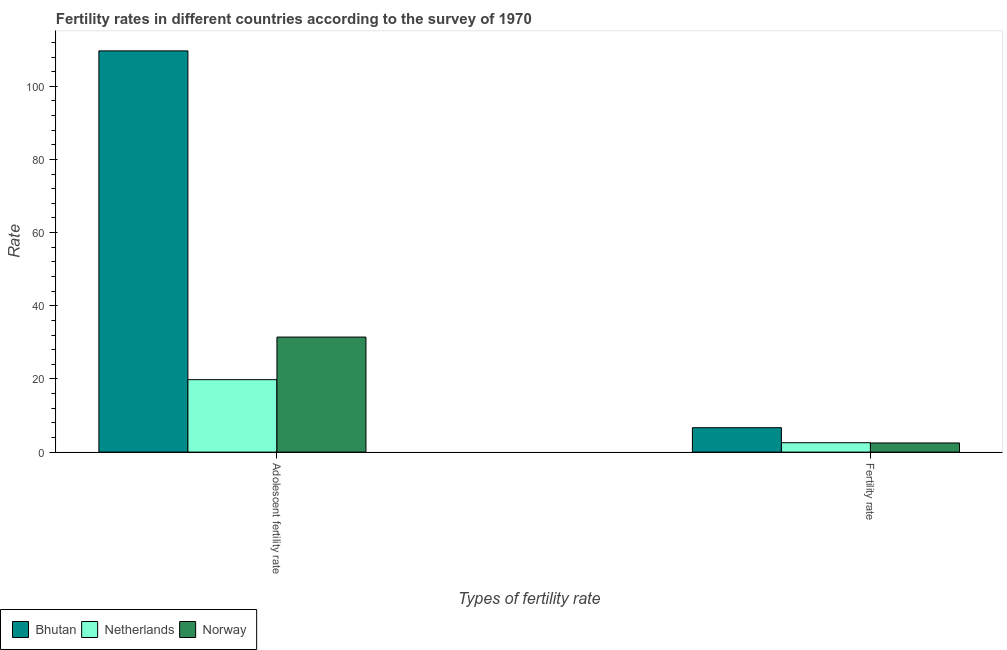How many different coloured bars are there?
Provide a succinct answer. 3. Are the number of bars per tick equal to the number of legend labels?
Ensure brevity in your answer.  Yes. Are the number of bars on each tick of the X-axis equal?
Keep it short and to the point. Yes. How many bars are there on the 2nd tick from the left?
Offer a terse response. 3. How many bars are there on the 1st tick from the right?
Give a very brief answer. 3. What is the label of the 2nd group of bars from the left?
Provide a short and direct response. Fertility rate. Across all countries, what is the maximum adolescent fertility rate?
Your answer should be very brief. 109.68. Across all countries, what is the minimum adolescent fertility rate?
Give a very brief answer. 19.8. In which country was the adolescent fertility rate maximum?
Provide a short and direct response. Bhutan. What is the total fertility rate in the graph?
Offer a terse response. 11.74. What is the difference between the fertility rate in Netherlands and that in Norway?
Offer a terse response. 0.07. What is the difference between the fertility rate in Netherlands and the adolescent fertility rate in Bhutan?
Offer a terse response. -107.11. What is the average fertility rate per country?
Ensure brevity in your answer.  3.91. What is the difference between the fertility rate and adolescent fertility rate in Bhutan?
Ensure brevity in your answer.  -103.01. In how many countries, is the fertility rate greater than 64 ?
Provide a short and direct response. 0. What is the ratio of the adolescent fertility rate in Norway to that in Netherlands?
Offer a terse response. 1.59. Is the fertility rate in Netherlands less than that in Norway?
Keep it short and to the point. No. What does the 1st bar from the left in Adolescent fertility rate represents?
Make the answer very short. Bhutan. How many bars are there?
Your answer should be very brief. 6. Are all the bars in the graph horizontal?
Your response must be concise. No. How many countries are there in the graph?
Provide a succinct answer. 3. Are the values on the major ticks of Y-axis written in scientific E-notation?
Your response must be concise. No. Does the graph contain grids?
Your answer should be very brief. No. Where does the legend appear in the graph?
Offer a very short reply. Bottom left. How many legend labels are there?
Keep it short and to the point. 3. How are the legend labels stacked?
Ensure brevity in your answer.  Horizontal. What is the title of the graph?
Provide a succinct answer. Fertility rates in different countries according to the survey of 1970. What is the label or title of the X-axis?
Your answer should be compact. Types of fertility rate. What is the label or title of the Y-axis?
Make the answer very short. Rate. What is the Rate in Bhutan in Adolescent fertility rate?
Provide a succinct answer. 109.68. What is the Rate in Netherlands in Adolescent fertility rate?
Your answer should be compact. 19.8. What is the Rate in Norway in Adolescent fertility rate?
Offer a terse response. 31.45. What is the Rate of Bhutan in Fertility rate?
Provide a short and direct response. 6.67. What is the Rate of Netherlands in Fertility rate?
Your response must be concise. 2.57. What is the Rate in Norway in Fertility rate?
Provide a succinct answer. 2.5. Across all Types of fertility rate, what is the maximum Rate of Bhutan?
Give a very brief answer. 109.68. Across all Types of fertility rate, what is the maximum Rate in Netherlands?
Your answer should be compact. 19.8. Across all Types of fertility rate, what is the maximum Rate of Norway?
Keep it short and to the point. 31.45. Across all Types of fertility rate, what is the minimum Rate in Bhutan?
Give a very brief answer. 6.67. Across all Types of fertility rate, what is the minimum Rate in Netherlands?
Provide a short and direct response. 2.57. Across all Types of fertility rate, what is the minimum Rate of Norway?
Ensure brevity in your answer.  2.5. What is the total Rate in Bhutan in the graph?
Your answer should be very brief. 116.35. What is the total Rate of Netherlands in the graph?
Your response must be concise. 22.38. What is the total Rate in Norway in the graph?
Your answer should be very brief. 33.95. What is the difference between the Rate of Bhutan in Adolescent fertility rate and that in Fertility rate?
Make the answer very short. 103.01. What is the difference between the Rate in Netherlands in Adolescent fertility rate and that in Fertility rate?
Keep it short and to the point. 17.23. What is the difference between the Rate of Norway in Adolescent fertility rate and that in Fertility rate?
Make the answer very short. 28.95. What is the difference between the Rate of Bhutan in Adolescent fertility rate and the Rate of Netherlands in Fertility rate?
Offer a very short reply. 107.11. What is the difference between the Rate in Bhutan in Adolescent fertility rate and the Rate in Norway in Fertility rate?
Ensure brevity in your answer.  107.18. What is the difference between the Rate in Netherlands in Adolescent fertility rate and the Rate in Norway in Fertility rate?
Offer a very short reply. 17.3. What is the average Rate of Bhutan per Types of fertility rate?
Keep it short and to the point. 58.18. What is the average Rate of Netherlands per Types of fertility rate?
Ensure brevity in your answer.  11.19. What is the average Rate of Norway per Types of fertility rate?
Offer a very short reply. 16.97. What is the difference between the Rate of Bhutan and Rate of Netherlands in Adolescent fertility rate?
Provide a succinct answer. 89.88. What is the difference between the Rate in Bhutan and Rate in Norway in Adolescent fertility rate?
Offer a terse response. 78.23. What is the difference between the Rate of Netherlands and Rate of Norway in Adolescent fertility rate?
Your answer should be compact. -11.64. What is the difference between the Rate of Bhutan and Rate of Netherlands in Fertility rate?
Provide a short and direct response. 4.1. What is the difference between the Rate of Bhutan and Rate of Norway in Fertility rate?
Ensure brevity in your answer.  4.17. What is the difference between the Rate in Netherlands and Rate in Norway in Fertility rate?
Give a very brief answer. 0.07. What is the ratio of the Rate of Bhutan in Adolescent fertility rate to that in Fertility rate?
Provide a succinct answer. 16.44. What is the ratio of the Rate in Netherlands in Adolescent fertility rate to that in Fertility rate?
Your answer should be compact. 7.71. What is the ratio of the Rate in Norway in Adolescent fertility rate to that in Fertility rate?
Your answer should be very brief. 12.58. What is the difference between the highest and the second highest Rate in Bhutan?
Give a very brief answer. 103.01. What is the difference between the highest and the second highest Rate in Netherlands?
Keep it short and to the point. 17.23. What is the difference between the highest and the second highest Rate of Norway?
Offer a terse response. 28.95. What is the difference between the highest and the lowest Rate of Bhutan?
Keep it short and to the point. 103.01. What is the difference between the highest and the lowest Rate in Netherlands?
Make the answer very short. 17.23. What is the difference between the highest and the lowest Rate in Norway?
Your answer should be compact. 28.95. 